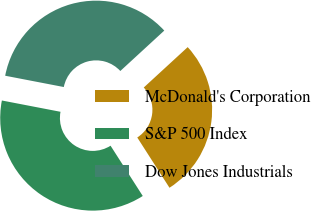<chart> <loc_0><loc_0><loc_500><loc_500><pie_chart><fcel>McDonald's Corporation<fcel>S&P 500 Index<fcel>Dow Jones Industrials<nl><fcel>27.76%<fcel>37.1%<fcel>35.14%<nl></chart> 